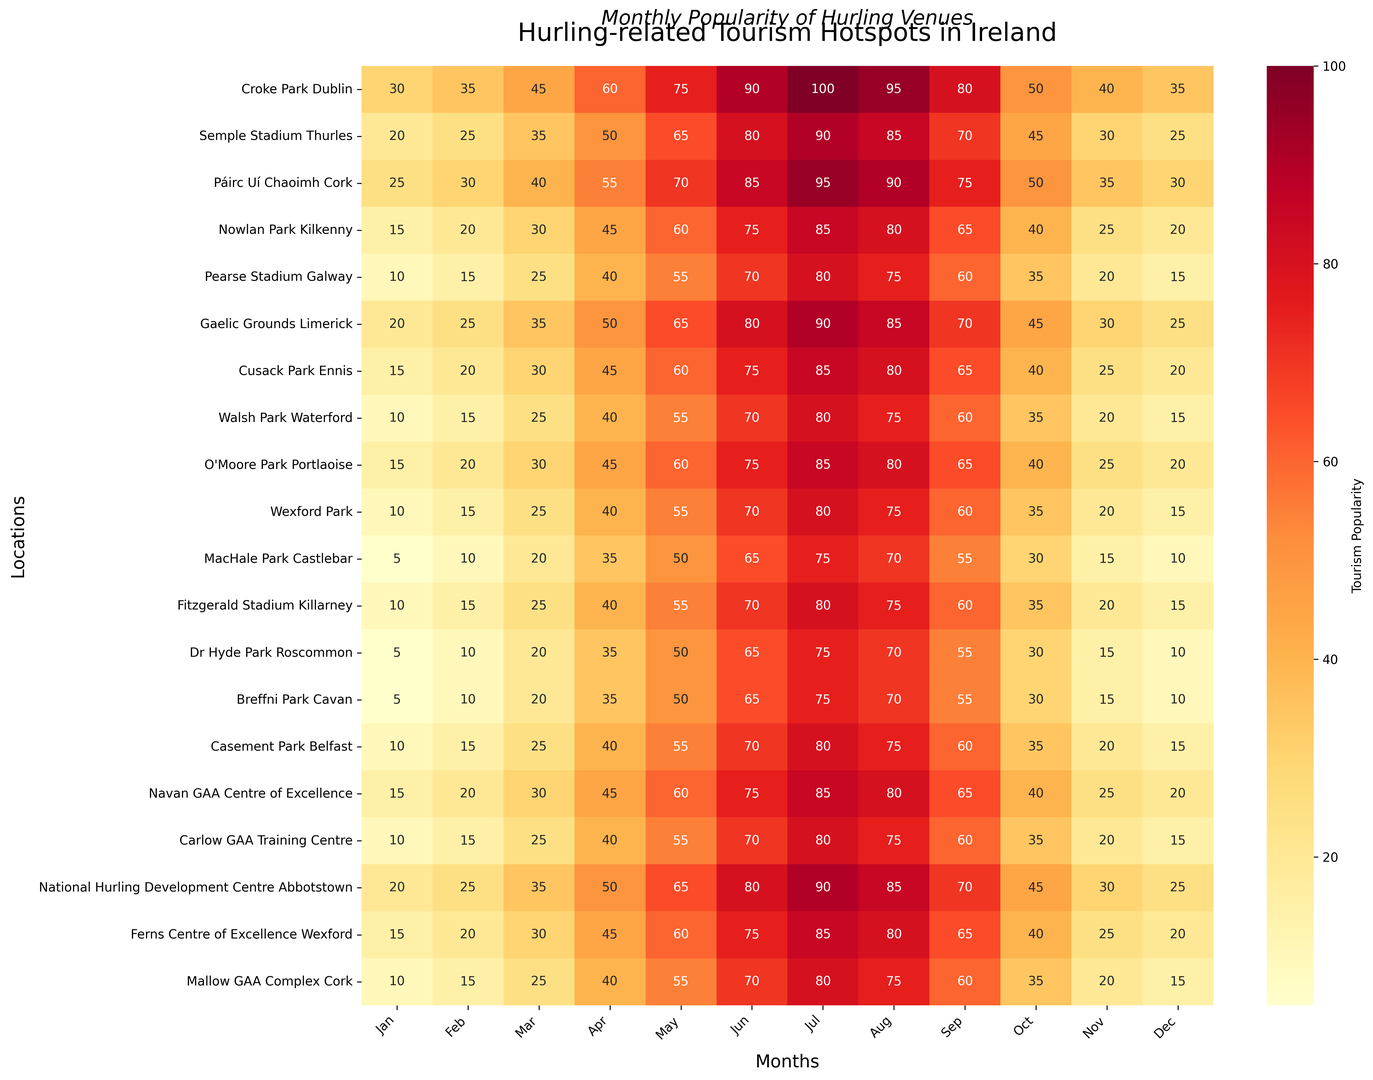Which location in Ireland has the highest tourist popularity in July? To determine the location with the highest tourist popularity in July, look at the July column and find the maximum value. The highest value is 100, located in "Croke Park Dublin."
Answer: Croke Park Dublin Which month sees the lowest tourist popularity at Walsh Park Waterford? In the row for "Walsh Park Waterford," identify the smallest number. The lowest value appears to be 10, which occurs in January.
Answer: January How does the tourist popularity in June compare between Páirc Uí Chaoimh Cork and Nowlan Park Kilkenny? Look at the values in the June column for both locations. Páirc Uí Chaoimh Cork has a value of 85, while Nowlan Park Kilkenny has a value of 75. Therefore, Páirc Uí Chaoimh Cork has higher popularity in June.
Answer: Páirc Uí Chaoimh Cork What is the average tourist popularity in August for all locations? Sum the tourism popularity values for all locations in August and divide by the number of locations. The sum is 95 + 85 + 90 + 80 + 75 + 85 + 80 + 75 + 80 + 75 + 70 + 75 + 70 + 70 + 75 + 80 + 75 + 85 + 80 + 75 = 1580. There are 20 locations, so the average is 1580 / 20 = 79.
Answer: 79 Which location has the least variation in tourist popularity between January and December? To find the location with the least variation, examine the range (difference between maximum and minimum values) for each location. Calculating the ranges: 
- Croke Park Dublin: 100 - 30 = 70
- Semple Stadium Thurles: 90 - 20 = 70
- Páirc Uí Chaoimh Cork: 95 - 25 = 70
- Nowlan Park Kilkenny: 85 - 15 = 70
- Pearse Stadium Galway: 80 - 10 = 70 
- Gaelic Grounds Limerick: 90 - 20 = 70
- Cusack Park Ennis: 85 - 15 = 70
- Walsh Park Waterford: 80 - 10 = 70
- O'Moore Park Portlaoise: 85 - 15 = 70
- Wexford Park: 80 - 10 = 70
- MacHale Park Castlebar: 75 - 5 = 70
- Fitzgerald Stadium Killarney: 80 - 10 = 70
- Dr Hyde Park Roscommon: 75 - 5 = 70
- Breffni Park Cavan: 75 - 5 = 70
- Casement Park Belfast: 80 - 10 = 70
- Navan GAA Centre of Excellence: 85 - 15 = 70
- Carlow GAA Training Centre: 80 - 10 = 70
- National Hurling Development Centre Abbotstown: 90 - 20 = 70
- Ferns Centre of Excellence Wexford: 85 - 15 = 70
- Mallow GAA Complex Cork: 80 - 10 = 70
All ranges are 70; hence all locations have equal variation.
Answer: All locations have equal variation In which month is the overall tourist popularity highest across all locations? Sum the values of each month column and compare. The sums are:
- Jan: 260
- Feb: 345
- Mar: 525
- Apr: 735
- May: 990
- Jun: 1215
- Jul: 1360
- Aug: 1315
- Sep: 1075
- Oct: 665
- Nov: 435
- Dec: 370
The highest sum is in July.
Answer: July Visually, which months have the highest intensity (darkest colors) overall? The heatmap’s darkest colors represent the highest values, which appear predominantly in June, July, and August. These months consistently show high tourist popularity across multiple locations.
Answer: June, July, and August 